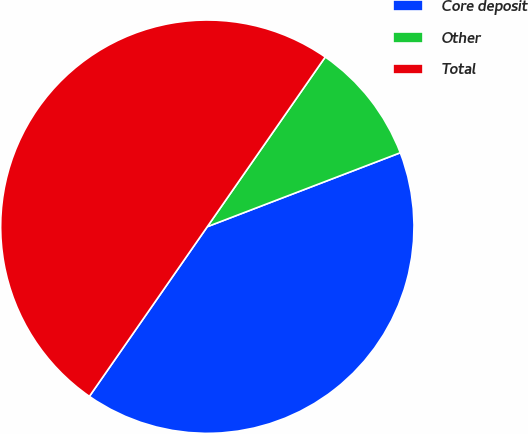Convert chart. <chart><loc_0><loc_0><loc_500><loc_500><pie_chart><fcel>Core deposit<fcel>Other<fcel>Total<nl><fcel>40.49%<fcel>9.51%<fcel>50.0%<nl></chart> 